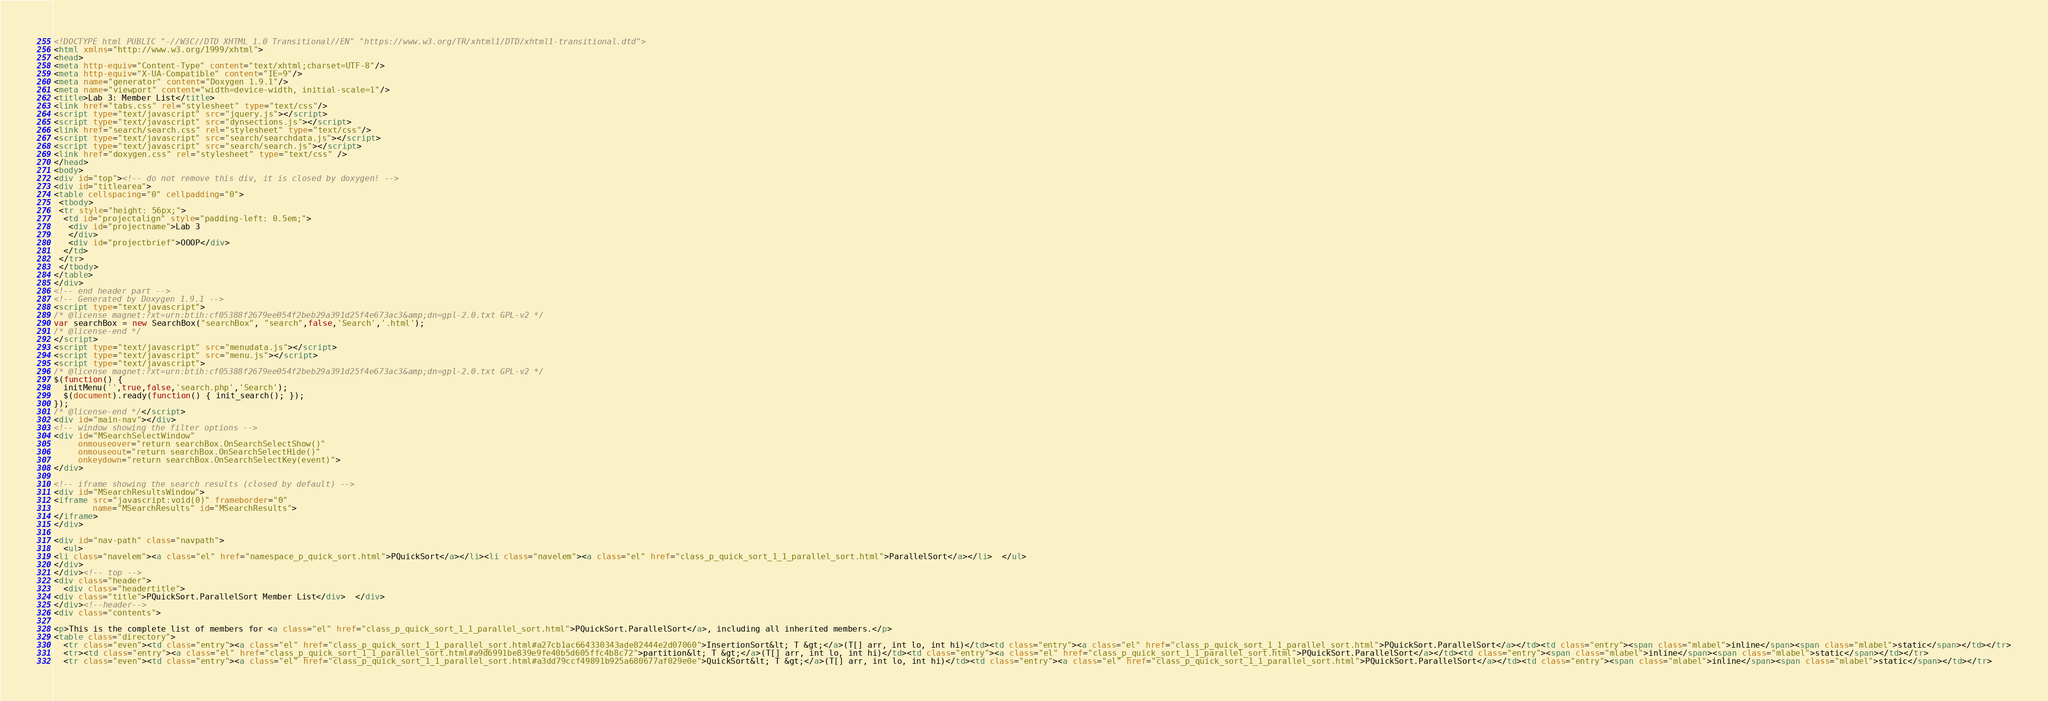<code> <loc_0><loc_0><loc_500><loc_500><_HTML_><!DOCTYPE html PUBLIC "-//W3C//DTD XHTML 1.0 Transitional//EN" "https://www.w3.org/TR/xhtml1/DTD/xhtml1-transitional.dtd">
<html xmlns="http://www.w3.org/1999/xhtml">
<head>
<meta http-equiv="Content-Type" content="text/xhtml;charset=UTF-8"/>
<meta http-equiv="X-UA-Compatible" content="IE=9"/>
<meta name="generator" content="Doxygen 1.9.1"/>
<meta name="viewport" content="width=device-width, initial-scale=1"/>
<title>Lab 3: Member List</title>
<link href="tabs.css" rel="stylesheet" type="text/css"/>
<script type="text/javascript" src="jquery.js"></script>
<script type="text/javascript" src="dynsections.js"></script>
<link href="search/search.css" rel="stylesheet" type="text/css"/>
<script type="text/javascript" src="search/searchdata.js"></script>
<script type="text/javascript" src="search/search.js"></script>
<link href="doxygen.css" rel="stylesheet" type="text/css" />
</head>
<body>
<div id="top"><!-- do not remove this div, it is closed by doxygen! -->
<div id="titlearea">
<table cellspacing="0" cellpadding="0">
 <tbody>
 <tr style="height: 56px;">
  <td id="projectalign" style="padding-left: 0.5em;">
   <div id="projectname">Lab 3
   </div>
   <div id="projectbrief">OOOP</div>
  </td>
 </tr>
 </tbody>
</table>
</div>
<!-- end header part -->
<!-- Generated by Doxygen 1.9.1 -->
<script type="text/javascript">
/* @license magnet:?xt=urn:btih:cf05388f2679ee054f2beb29a391d25f4e673ac3&amp;dn=gpl-2.0.txt GPL-v2 */
var searchBox = new SearchBox("searchBox", "search",false,'Search','.html');
/* @license-end */
</script>
<script type="text/javascript" src="menudata.js"></script>
<script type="text/javascript" src="menu.js"></script>
<script type="text/javascript">
/* @license magnet:?xt=urn:btih:cf05388f2679ee054f2beb29a391d25f4e673ac3&amp;dn=gpl-2.0.txt GPL-v2 */
$(function() {
  initMenu('',true,false,'search.php','Search');
  $(document).ready(function() { init_search(); });
});
/* @license-end */</script>
<div id="main-nav"></div>
<!-- window showing the filter options -->
<div id="MSearchSelectWindow"
     onmouseover="return searchBox.OnSearchSelectShow()"
     onmouseout="return searchBox.OnSearchSelectHide()"
     onkeydown="return searchBox.OnSearchSelectKey(event)">
</div>

<!-- iframe showing the search results (closed by default) -->
<div id="MSearchResultsWindow">
<iframe src="javascript:void(0)" frameborder="0" 
        name="MSearchResults" id="MSearchResults">
</iframe>
</div>

<div id="nav-path" class="navpath">
  <ul>
<li class="navelem"><a class="el" href="namespace_p_quick_sort.html">PQuickSort</a></li><li class="navelem"><a class="el" href="class_p_quick_sort_1_1_parallel_sort.html">ParallelSort</a></li>  </ul>
</div>
</div><!-- top -->
<div class="header">
  <div class="headertitle">
<div class="title">PQuickSort.ParallelSort Member List</div>  </div>
</div><!--header-->
<div class="contents">

<p>This is the complete list of members for <a class="el" href="class_p_quick_sort_1_1_parallel_sort.html">PQuickSort.ParallelSort</a>, including all inherited members.</p>
<table class="directory">
  <tr class="even"><td class="entry"><a class="el" href="class_p_quick_sort_1_1_parallel_sort.html#a27cb1ac664330343ade82444e2d07060">InsertionSort&lt; T &gt;</a>(T[] arr, int lo, int hi)</td><td class="entry"><a class="el" href="class_p_quick_sort_1_1_parallel_sort.html">PQuickSort.ParallelSort</a></td><td class="entry"><span class="mlabel">inline</span><span class="mlabel">static</span></td></tr>
  <tr><td class="entry"><a class="el" href="class_p_quick_sort_1_1_parallel_sort.html#a9d6991be839e9fe40b5d605ffc4b8c72">partition&lt; T &gt;</a>(T[] arr, int lo, int hi)</td><td class="entry"><a class="el" href="class_p_quick_sort_1_1_parallel_sort.html">PQuickSort.ParallelSort</a></td><td class="entry"><span class="mlabel">inline</span><span class="mlabel">static</span></td></tr>
  <tr class="even"><td class="entry"><a class="el" href="class_p_quick_sort_1_1_parallel_sort.html#a3dd79ccf49891b925a680677af029e0e">QuickSort&lt; T &gt;</a>(T[] arr, int lo, int hi)</td><td class="entry"><a class="el" href="class_p_quick_sort_1_1_parallel_sort.html">PQuickSort.ParallelSort</a></td><td class="entry"><span class="mlabel">inline</span><span class="mlabel">static</span></td></tr></code> 